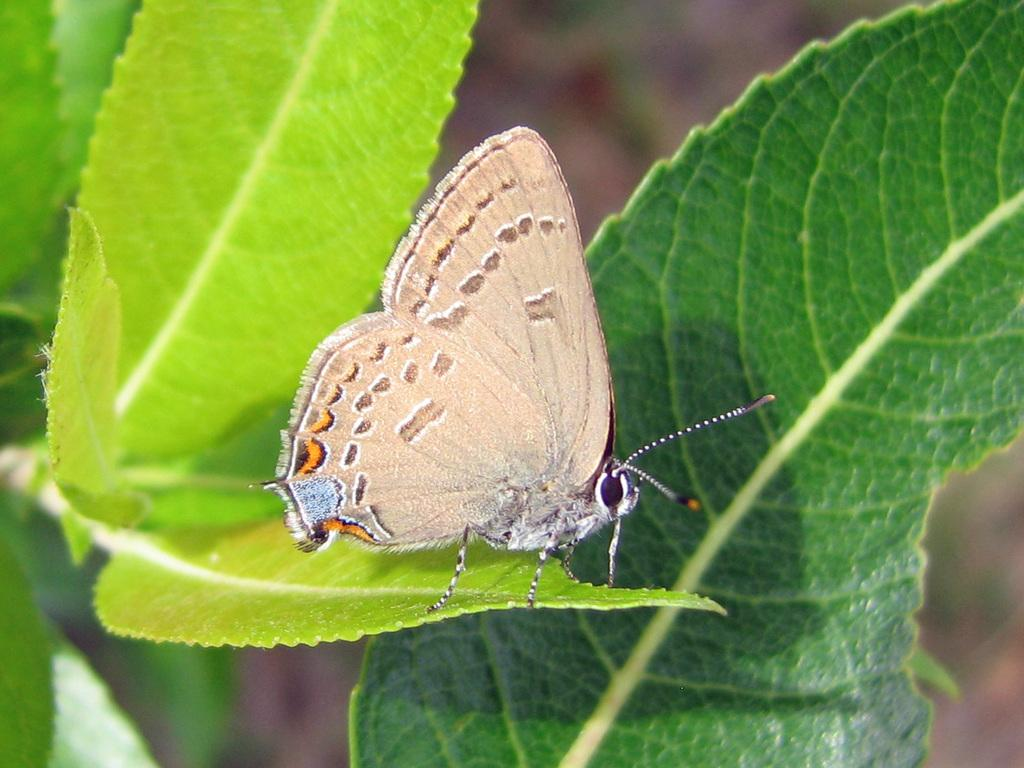What is the main subject of the image? There is a butterfly in the image. Where is the butterfly located? The butterfly is on a leaf. What is the position of the leaf in the image? The leaf is in the center of the image. How would you describe the background of the image? The background of the image is blurry. What else can be seen in the image besides the butterfly and leaf? Leaves are visible in the front of the image. Is there a tiger attacking the butterfly in the image? No, there is no tiger or any attack present in the image. The image only features a butterfly on a leaf, with leaves visible in the front and a blurry background. 